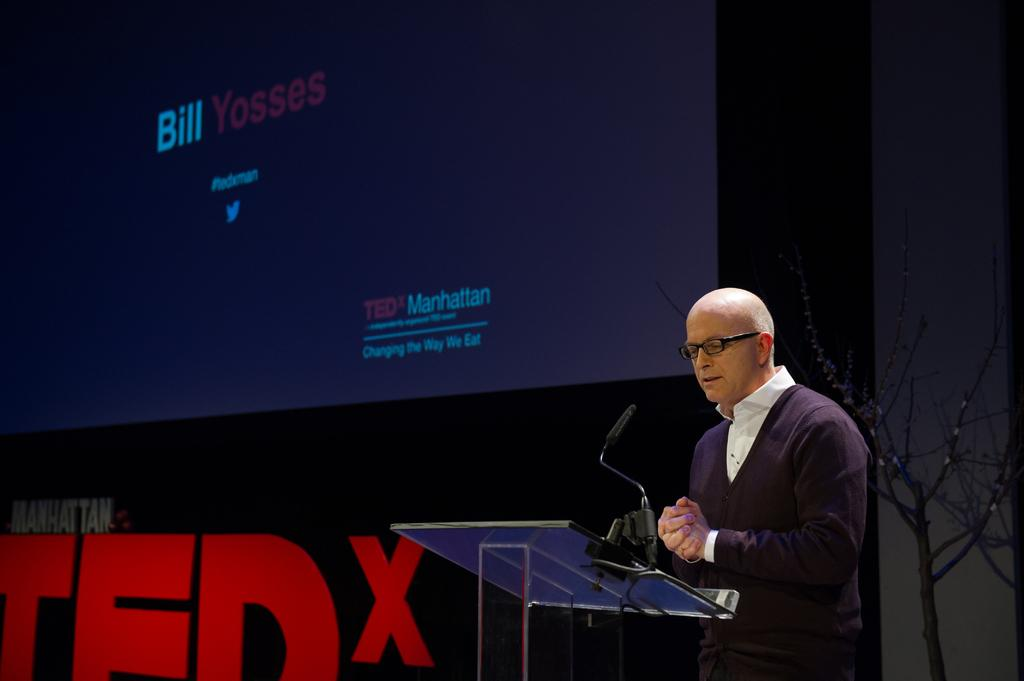What is the main object in the image? There is a screen in the image. What else can be seen in the background? There is a wall in the image. Are there any plants visible? Yes, there is a dry plant in the image. What other equipment is present? There is a mic in the image. Can you describe the person in the image? There is a person wearing a black color jacket in the image. How many wrens are perched on the person's finger in the image? There are no wrens present in the image, and the person's finger is not visible. 